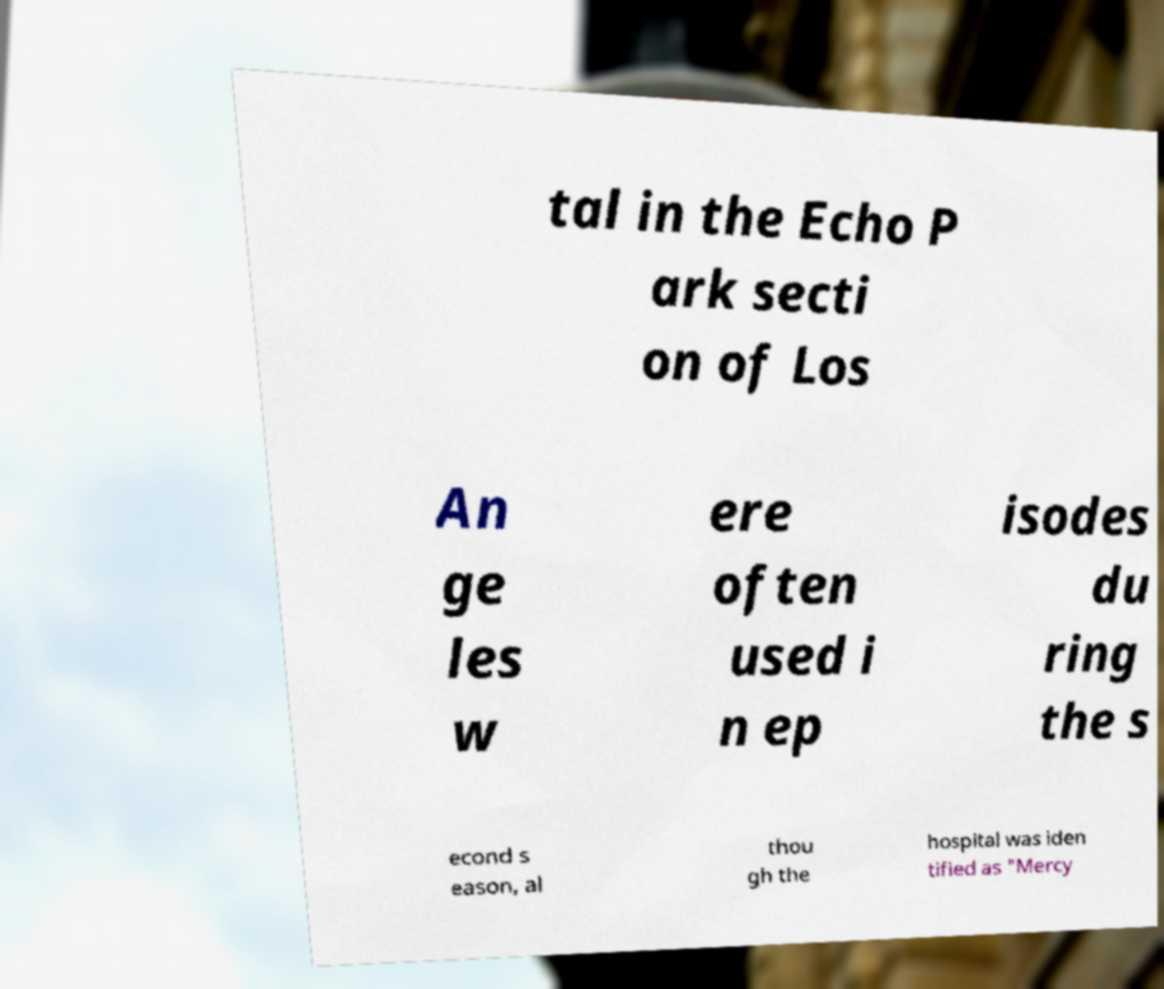Please read and relay the text visible in this image. What does it say? tal in the Echo P ark secti on of Los An ge les w ere often used i n ep isodes du ring the s econd s eason, al thou gh the hospital was iden tified as "Mercy 